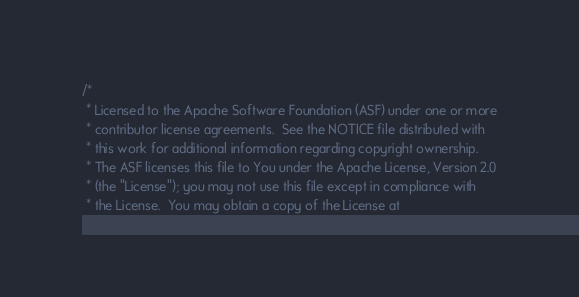<code> <loc_0><loc_0><loc_500><loc_500><_Scala_>/*
 * Licensed to the Apache Software Foundation (ASF) under one or more
 * contributor license agreements.  See the NOTICE file distributed with
 * this work for additional information regarding copyright ownership.
 * The ASF licenses this file to You under the Apache License, Version 2.0
 * (the "License"); you may not use this file except in compliance with
 * the License.  You may obtain a copy of the License at</code> 